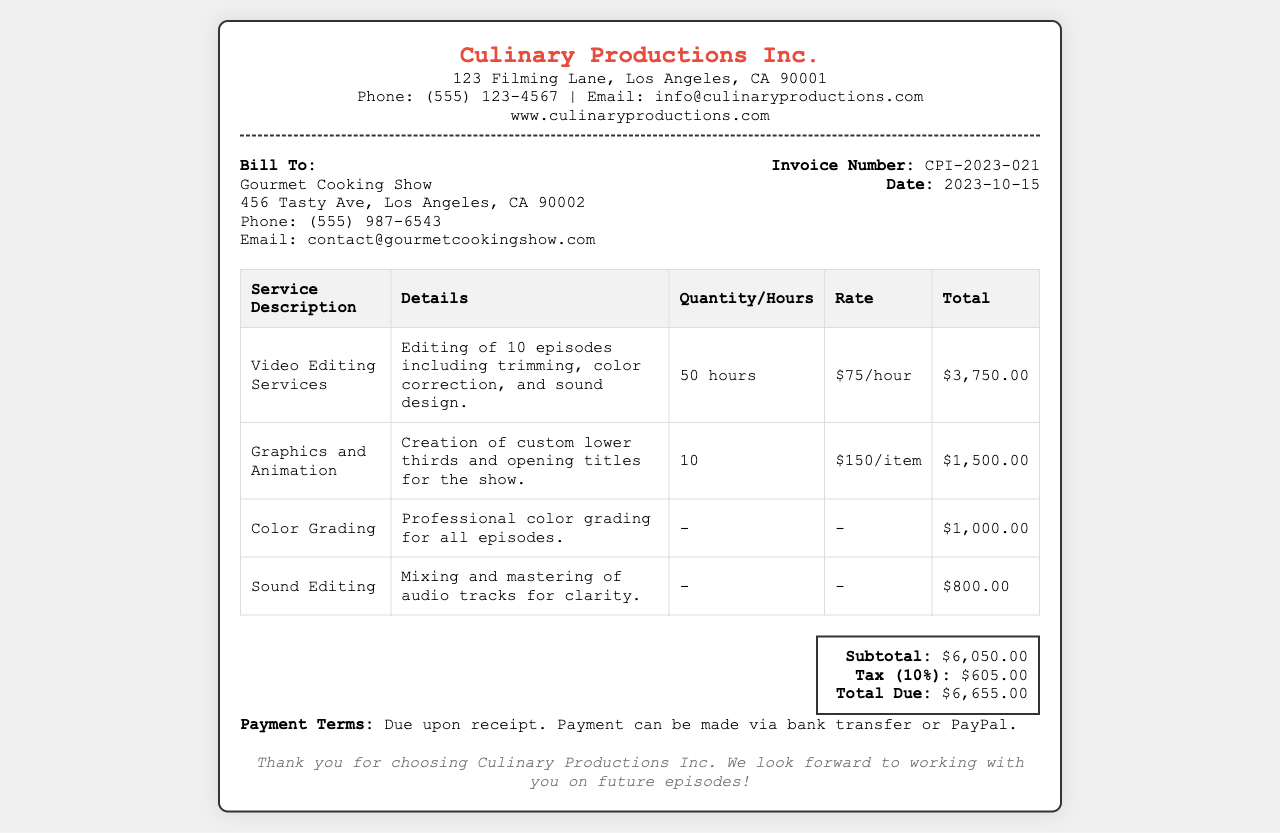What is the company name? The company name listed at the top of the receipt is "Culinary Productions Inc."
Answer: Culinary Productions Inc What is the invoice number? The unique invoice identifier provided on the receipt is "CPI-2023-021."
Answer: CPI-2023-021 How much was charged for video editing services? The total amount charged for video editing services is detailed as "$3,750.00."
Answer: $3,750.00 What is the total due amount? The total due amount, including tax, is specified as "$6,655.00."
Answer: $6,655.00 What is the tax percentage applied? The tax percentage stated in the document is "10%."
Answer: 10% What service includes custom graphics? The service for custom graphics is specified as "Graphics and Animation."
Answer: Graphics and Animation What is the payment term? The payment term stated in the receipt is "Due upon receipt."
Answer: Due upon receipt How many episodes were edited? The document mentions editing "10 episodes."
Answer: 10 episodes What is the total for sound editing? The total amount for sound editing services is "$800.00."
Answer: $800.00 